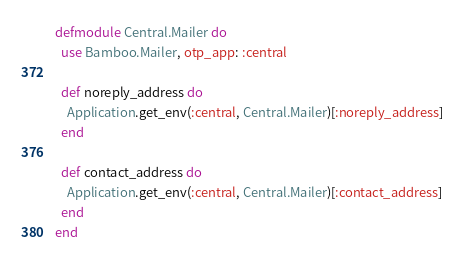Convert code to text. <code><loc_0><loc_0><loc_500><loc_500><_Elixir_>defmodule Central.Mailer do
  use Bamboo.Mailer, otp_app: :central

  def noreply_address do
    Application.get_env(:central, Central.Mailer)[:noreply_address]
  end

  def contact_address do
    Application.get_env(:central, Central.Mailer)[:contact_address]
  end
end
</code> 